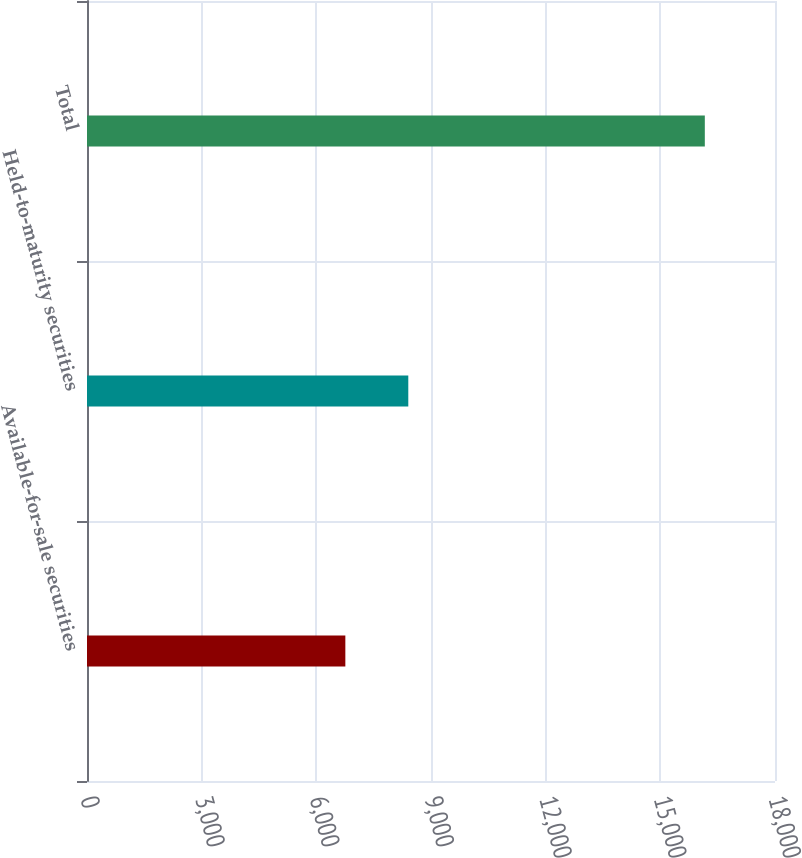Convert chart to OTSL. <chart><loc_0><loc_0><loc_500><loc_500><bar_chart><fcel>Available-for-sale securities<fcel>Held-to-maturity securities<fcel>Total<nl><fcel>6759<fcel>8406<fcel>16164<nl></chart> 